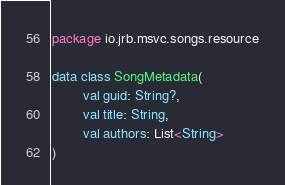Convert code to text. <code><loc_0><loc_0><loc_500><loc_500><_Kotlin_>package io.jrb.msvc.songs.resource

data class SongMetadata(
        val guid: String?,
        val title: String,
        val authors: List<String>
)
</code> 